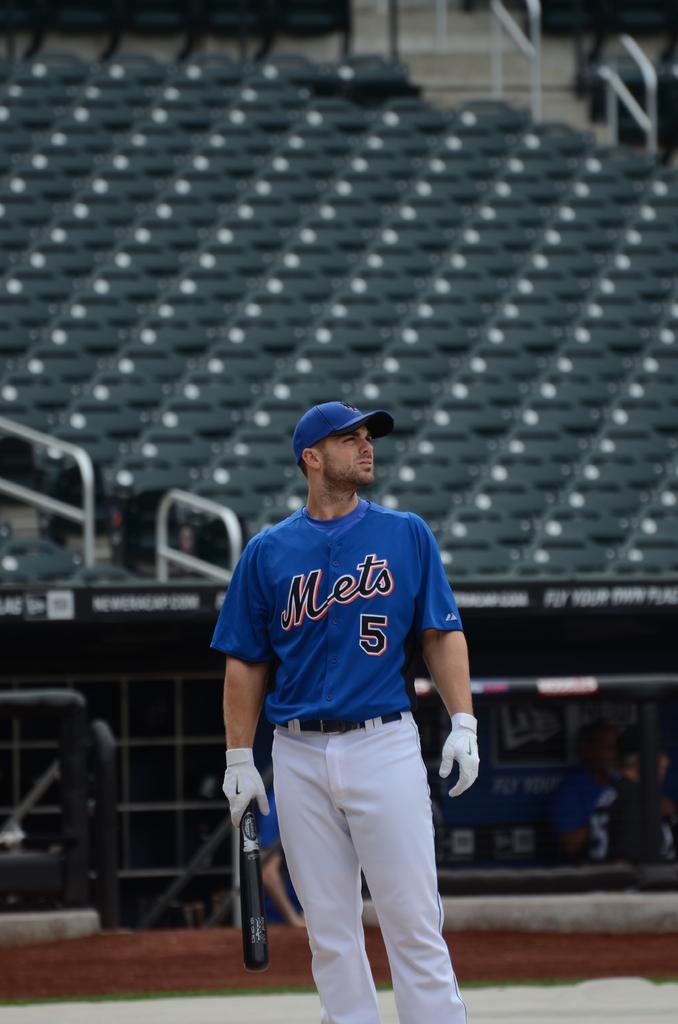Which professional baseball team does the man play for?
Ensure brevity in your answer.  Mets. What is the player's number?
Offer a terse response. 5. 